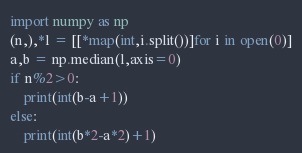Convert code to text. <code><loc_0><loc_0><loc_500><loc_500><_Python_>import numpy as np
(n,),*l = [[*map(int,i.split())]for i in open(0)]
a,b = np.median(l,axis=0)
if n%2>0:
    print(int(b-a+1))
else:
    print(int(b*2-a*2)+1)</code> 